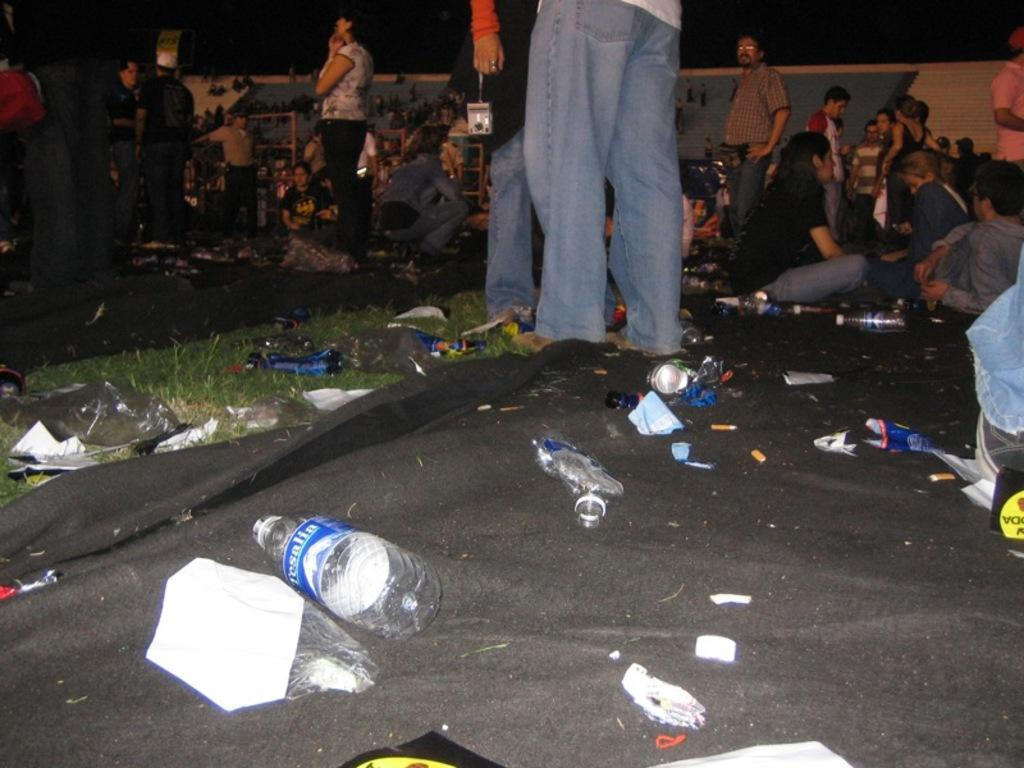What are the people in the image doing? There are persons standing and sitting on the grass in the image. What is the cloth used for in the image? The cloth is used to hold bottles and other things in the image. How many bottles are on the cloth? There are bottles on the cloth in the image. What else can be found on the cloth besides the bottles? There are other things on the cloth in the image. What type of seed is being planted by the persons in the image? There is no indication of planting or seeds in the image; the persons are standing and sitting on the grass. 